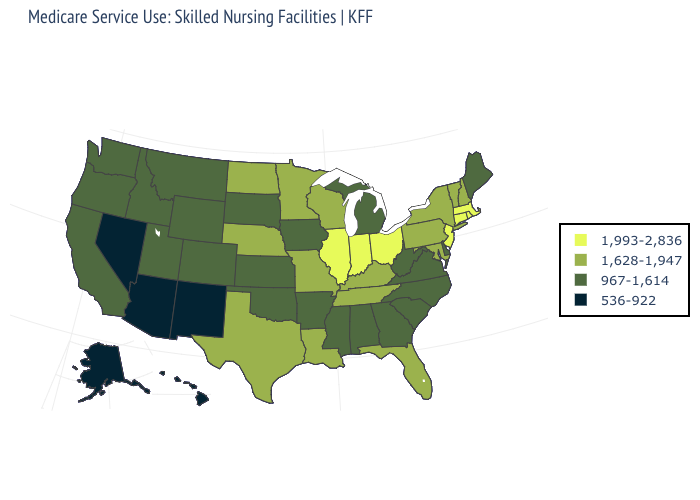What is the value of Hawaii?
Be succinct. 536-922. Among the states that border West Virginia , does Virginia have the lowest value?
Be succinct. Yes. What is the value of Alabama?
Concise answer only. 967-1,614. What is the highest value in states that border Idaho?
Keep it brief. 967-1,614. Does South Dakota have a higher value than Arizona?
Answer briefly. Yes. What is the highest value in states that border New Mexico?
Give a very brief answer. 1,628-1,947. What is the value of Florida?
Give a very brief answer. 1,628-1,947. Name the states that have a value in the range 1,628-1,947?
Quick response, please. Florida, Kentucky, Louisiana, Maryland, Minnesota, Missouri, Nebraska, New Hampshire, New York, North Dakota, Pennsylvania, Tennessee, Texas, Vermont, Wisconsin. Among the states that border Utah , does Idaho have the lowest value?
Concise answer only. No. Which states have the lowest value in the Northeast?
Quick response, please. Maine. What is the value of New York?
Concise answer only. 1,628-1,947. Does Oregon have the same value as Kentucky?
Short answer required. No. Does Pennsylvania have the lowest value in the Northeast?
Concise answer only. No. What is the value of North Dakota?
Concise answer only. 1,628-1,947. Name the states that have a value in the range 967-1,614?
Concise answer only. Alabama, Arkansas, California, Colorado, Delaware, Georgia, Idaho, Iowa, Kansas, Maine, Michigan, Mississippi, Montana, North Carolina, Oklahoma, Oregon, South Carolina, South Dakota, Utah, Virginia, Washington, West Virginia, Wyoming. 